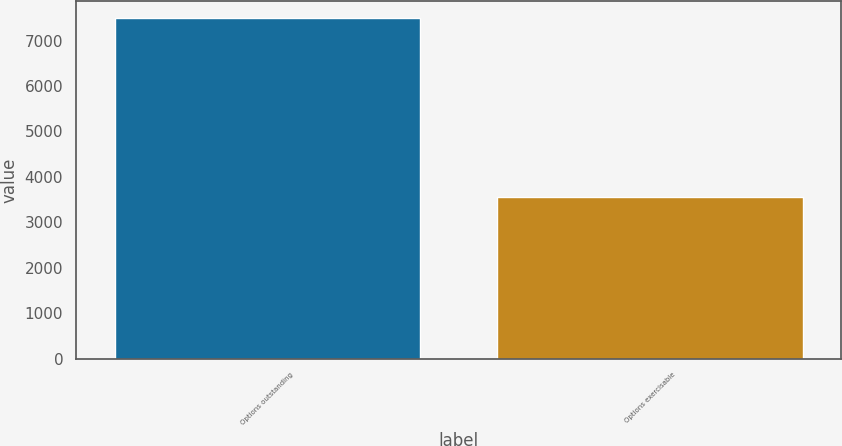Convert chart to OTSL. <chart><loc_0><loc_0><loc_500><loc_500><bar_chart><fcel>Options outstanding<fcel>Options exercisable<nl><fcel>7488<fcel>3555<nl></chart> 